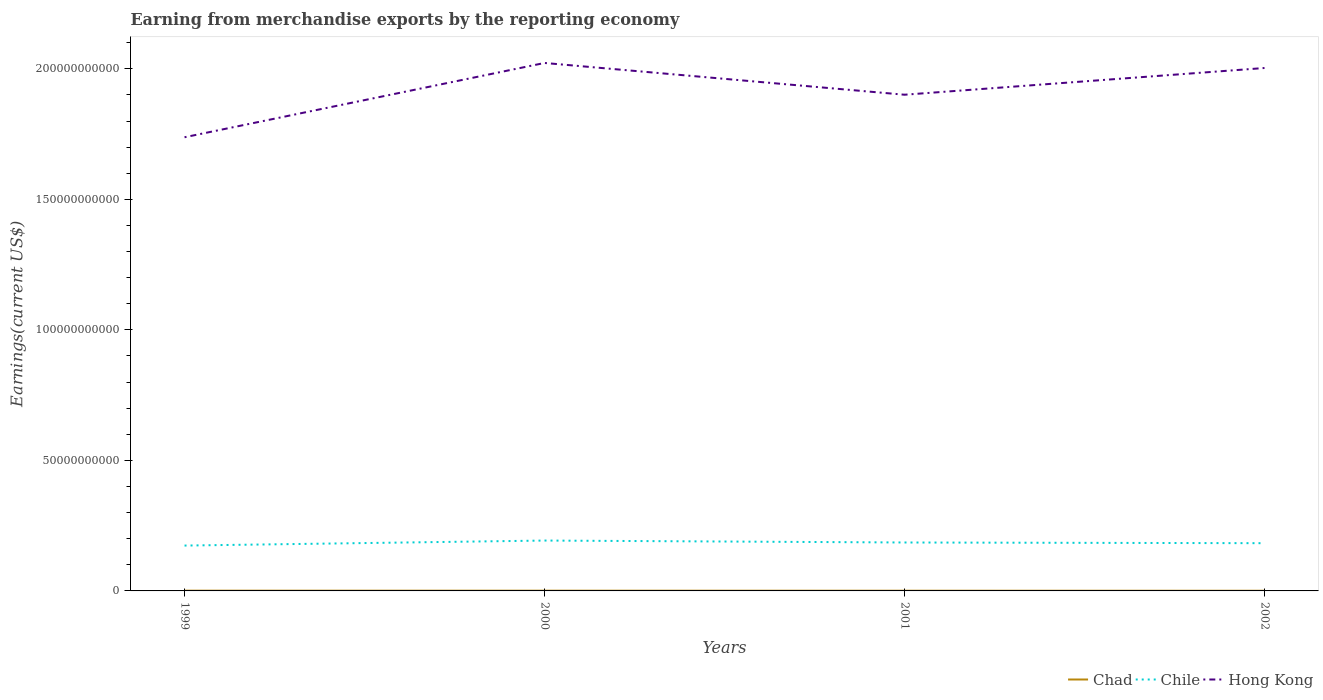Does the line corresponding to Chile intersect with the line corresponding to Chad?
Give a very brief answer. No. Is the number of lines equal to the number of legend labels?
Offer a terse response. Yes. Across all years, what is the maximum amount earned from merchandise exports in Chad?
Make the answer very short. 6.39e+07. In which year was the amount earned from merchandise exports in Chile maximum?
Your answer should be very brief. 1999. What is the total amount earned from merchandise exports in Chile in the graph?
Your answer should be very brief. -1.18e+09. What is the difference between the highest and the second highest amount earned from merchandise exports in Chile?
Ensure brevity in your answer.  1.92e+09. What is the difference between the highest and the lowest amount earned from merchandise exports in Chile?
Give a very brief answer. 2. How many lines are there?
Keep it short and to the point. 3. Are the values on the major ticks of Y-axis written in scientific E-notation?
Your answer should be very brief. No. Does the graph contain any zero values?
Your response must be concise. No. Where does the legend appear in the graph?
Offer a very short reply. Bottom right. How many legend labels are there?
Keep it short and to the point. 3. How are the legend labels stacked?
Your answer should be very brief. Horizontal. What is the title of the graph?
Offer a very short reply. Earning from merchandise exports by the reporting economy. What is the label or title of the Y-axis?
Your response must be concise. Earnings(current US$). What is the Earnings(current US$) of Chad in 1999?
Give a very brief answer. 9.81e+07. What is the Earnings(current US$) of Chile in 1999?
Ensure brevity in your answer.  1.74e+1. What is the Earnings(current US$) of Hong Kong in 1999?
Your answer should be compact. 1.74e+11. What is the Earnings(current US$) in Chad in 2000?
Ensure brevity in your answer.  8.76e+07. What is the Earnings(current US$) of Chile in 2000?
Your answer should be compact. 1.93e+1. What is the Earnings(current US$) of Hong Kong in 2000?
Make the answer very short. 2.02e+11. What is the Earnings(current US$) in Chad in 2001?
Your response must be concise. 7.66e+07. What is the Earnings(current US$) in Chile in 2001?
Offer a terse response. 1.86e+1. What is the Earnings(current US$) of Hong Kong in 2001?
Ensure brevity in your answer.  1.90e+11. What is the Earnings(current US$) in Chad in 2002?
Ensure brevity in your answer.  6.39e+07. What is the Earnings(current US$) of Chile in 2002?
Keep it short and to the point. 1.83e+1. What is the Earnings(current US$) of Hong Kong in 2002?
Keep it short and to the point. 2.00e+11. Across all years, what is the maximum Earnings(current US$) in Chad?
Keep it short and to the point. 9.81e+07. Across all years, what is the maximum Earnings(current US$) of Chile?
Give a very brief answer. 1.93e+1. Across all years, what is the maximum Earnings(current US$) in Hong Kong?
Give a very brief answer. 2.02e+11. Across all years, what is the minimum Earnings(current US$) in Chad?
Your answer should be compact. 6.39e+07. Across all years, what is the minimum Earnings(current US$) of Chile?
Your answer should be very brief. 1.74e+1. Across all years, what is the minimum Earnings(current US$) of Hong Kong?
Provide a short and direct response. 1.74e+11. What is the total Earnings(current US$) in Chad in the graph?
Keep it short and to the point. 3.26e+08. What is the total Earnings(current US$) of Chile in the graph?
Provide a succinct answer. 7.35e+1. What is the total Earnings(current US$) in Hong Kong in the graph?
Keep it short and to the point. 7.66e+11. What is the difference between the Earnings(current US$) in Chad in 1999 and that in 2000?
Provide a short and direct response. 1.05e+07. What is the difference between the Earnings(current US$) of Chile in 1999 and that in 2000?
Keep it short and to the point. -1.92e+09. What is the difference between the Earnings(current US$) of Hong Kong in 1999 and that in 2000?
Offer a very short reply. -2.85e+1. What is the difference between the Earnings(current US$) in Chad in 1999 and that in 2001?
Provide a short and direct response. 2.15e+07. What is the difference between the Earnings(current US$) in Chile in 1999 and that in 2001?
Make the answer very short. -1.18e+09. What is the difference between the Earnings(current US$) in Hong Kong in 1999 and that in 2001?
Provide a succinct answer. -1.63e+1. What is the difference between the Earnings(current US$) of Chad in 1999 and that in 2002?
Offer a very short reply. 3.42e+07. What is the difference between the Earnings(current US$) of Chile in 1999 and that in 2002?
Give a very brief answer. -9.09e+08. What is the difference between the Earnings(current US$) of Hong Kong in 1999 and that in 2002?
Your answer should be compact. -2.65e+1. What is the difference between the Earnings(current US$) of Chad in 2000 and that in 2001?
Provide a succinct answer. 1.10e+07. What is the difference between the Earnings(current US$) in Chile in 2000 and that in 2001?
Offer a very short reply. 7.41e+08. What is the difference between the Earnings(current US$) of Hong Kong in 2000 and that in 2001?
Your response must be concise. 1.22e+1. What is the difference between the Earnings(current US$) of Chad in 2000 and that in 2002?
Offer a terse response. 2.37e+07. What is the difference between the Earnings(current US$) in Chile in 2000 and that in 2002?
Your answer should be compact. 1.01e+09. What is the difference between the Earnings(current US$) of Hong Kong in 2000 and that in 2002?
Your answer should be compact. 1.93e+09. What is the difference between the Earnings(current US$) of Chad in 2001 and that in 2002?
Your response must be concise. 1.27e+07. What is the difference between the Earnings(current US$) of Chile in 2001 and that in 2002?
Ensure brevity in your answer.  2.69e+08. What is the difference between the Earnings(current US$) in Hong Kong in 2001 and that in 2002?
Give a very brief answer. -1.02e+1. What is the difference between the Earnings(current US$) in Chad in 1999 and the Earnings(current US$) in Chile in 2000?
Provide a short and direct response. -1.92e+1. What is the difference between the Earnings(current US$) in Chad in 1999 and the Earnings(current US$) in Hong Kong in 2000?
Ensure brevity in your answer.  -2.02e+11. What is the difference between the Earnings(current US$) in Chile in 1999 and the Earnings(current US$) in Hong Kong in 2000?
Provide a succinct answer. -1.85e+11. What is the difference between the Earnings(current US$) of Chad in 1999 and the Earnings(current US$) of Chile in 2001?
Your answer should be compact. -1.85e+1. What is the difference between the Earnings(current US$) of Chad in 1999 and the Earnings(current US$) of Hong Kong in 2001?
Give a very brief answer. -1.90e+11. What is the difference between the Earnings(current US$) in Chile in 1999 and the Earnings(current US$) in Hong Kong in 2001?
Offer a very short reply. -1.73e+11. What is the difference between the Earnings(current US$) in Chad in 1999 and the Earnings(current US$) in Chile in 2002?
Provide a succinct answer. -1.82e+1. What is the difference between the Earnings(current US$) of Chad in 1999 and the Earnings(current US$) of Hong Kong in 2002?
Your answer should be very brief. -2.00e+11. What is the difference between the Earnings(current US$) of Chile in 1999 and the Earnings(current US$) of Hong Kong in 2002?
Provide a short and direct response. -1.83e+11. What is the difference between the Earnings(current US$) of Chad in 2000 and the Earnings(current US$) of Chile in 2001?
Your response must be concise. -1.85e+1. What is the difference between the Earnings(current US$) in Chad in 2000 and the Earnings(current US$) in Hong Kong in 2001?
Ensure brevity in your answer.  -1.90e+11. What is the difference between the Earnings(current US$) of Chile in 2000 and the Earnings(current US$) of Hong Kong in 2001?
Keep it short and to the point. -1.71e+11. What is the difference between the Earnings(current US$) of Chad in 2000 and the Earnings(current US$) of Chile in 2002?
Your response must be concise. -1.82e+1. What is the difference between the Earnings(current US$) in Chad in 2000 and the Earnings(current US$) in Hong Kong in 2002?
Your answer should be compact. -2.00e+11. What is the difference between the Earnings(current US$) in Chile in 2000 and the Earnings(current US$) in Hong Kong in 2002?
Keep it short and to the point. -1.81e+11. What is the difference between the Earnings(current US$) of Chad in 2001 and the Earnings(current US$) of Chile in 2002?
Offer a very short reply. -1.82e+1. What is the difference between the Earnings(current US$) of Chad in 2001 and the Earnings(current US$) of Hong Kong in 2002?
Provide a short and direct response. -2.00e+11. What is the difference between the Earnings(current US$) in Chile in 2001 and the Earnings(current US$) in Hong Kong in 2002?
Provide a short and direct response. -1.82e+11. What is the average Earnings(current US$) in Chad per year?
Keep it short and to the point. 8.15e+07. What is the average Earnings(current US$) in Chile per year?
Keep it short and to the point. 1.84e+1. What is the average Earnings(current US$) of Hong Kong per year?
Your response must be concise. 1.92e+11. In the year 1999, what is the difference between the Earnings(current US$) of Chad and Earnings(current US$) of Chile?
Offer a very short reply. -1.73e+1. In the year 1999, what is the difference between the Earnings(current US$) in Chad and Earnings(current US$) in Hong Kong?
Offer a very short reply. -1.74e+11. In the year 1999, what is the difference between the Earnings(current US$) of Chile and Earnings(current US$) of Hong Kong?
Provide a short and direct response. -1.56e+11. In the year 2000, what is the difference between the Earnings(current US$) in Chad and Earnings(current US$) in Chile?
Make the answer very short. -1.92e+1. In the year 2000, what is the difference between the Earnings(current US$) of Chad and Earnings(current US$) of Hong Kong?
Offer a very short reply. -2.02e+11. In the year 2000, what is the difference between the Earnings(current US$) of Chile and Earnings(current US$) of Hong Kong?
Provide a succinct answer. -1.83e+11. In the year 2001, what is the difference between the Earnings(current US$) of Chad and Earnings(current US$) of Chile?
Make the answer very short. -1.85e+1. In the year 2001, what is the difference between the Earnings(current US$) of Chad and Earnings(current US$) of Hong Kong?
Your response must be concise. -1.90e+11. In the year 2001, what is the difference between the Earnings(current US$) in Chile and Earnings(current US$) in Hong Kong?
Give a very brief answer. -1.72e+11. In the year 2002, what is the difference between the Earnings(current US$) in Chad and Earnings(current US$) in Chile?
Provide a succinct answer. -1.82e+1. In the year 2002, what is the difference between the Earnings(current US$) in Chad and Earnings(current US$) in Hong Kong?
Your answer should be very brief. -2.00e+11. In the year 2002, what is the difference between the Earnings(current US$) of Chile and Earnings(current US$) of Hong Kong?
Your answer should be compact. -1.82e+11. What is the ratio of the Earnings(current US$) of Chad in 1999 to that in 2000?
Your answer should be very brief. 1.12. What is the ratio of the Earnings(current US$) of Chile in 1999 to that in 2000?
Offer a terse response. 0.9. What is the ratio of the Earnings(current US$) in Hong Kong in 1999 to that in 2000?
Offer a very short reply. 0.86. What is the ratio of the Earnings(current US$) of Chad in 1999 to that in 2001?
Provide a succinct answer. 1.28. What is the ratio of the Earnings(current US$) in Chile in 1999 to that in 2001?
Your response must be concise. 0.94. What is the ratio of the Earnings(current US$) of Hong Kong in 1999 to that in 2001?
Provide a succinct answer. 0.91. What is the ratio of the Earnings(current US$) in Chad in 1999 to that in 2002?
Offer a very short reply. 1.54. What is the ratio of the Earnings(current US$) of Chile in 1999 to that in 2002?
Make the answer very short. 0.95. What is the ratio of the Earnings(current US$) of Hong Kong in 1999 to that in 2002?
Provide a short and direct response. 0.87. What is the ratio of the Earnings(current US$) of Chad in 2000 to that in 2001?
Offer a very short reply. 1.14. What is the ratio of the Earnings(current US$) in Chile in 2000 to that in 2001?
Your answer should be compact. 1.04. What is the ratio of the Earnings(current US$) of Hong Kong in 2000 to that in 2001?
Keep it short and to the point. 1.06. What is the ratio of the Earnings(current US$) in Chad in 2000 to that in 2002?
Provide a succinct answer. 1.37. What is the ratio of the Earnings(current US$) in Chile in 2000 to that in 2002?
Provide a short and direct response. 1.06. What is the ratio of the Earnings(current US$) in Hong Kong in 2000 to that in 2002?
Provide a succinct answer. 1.01. What is the ratio of the Earnings(current US$) in Chad in 2001 to that in 2002?
Ensure brevity in your answer.  1.2. What is the ratio of the Earnings(current US$) of Chile in 2001 to that in 2002?
Your answer should be very brief. 1.01. What is the ratio of the Earnings(current US$) of Hong Kong in 2001 to that in 2002?
Offer a terse response. 0.95. What is the difference between the highest and the second highest Earnings(current US$) of Chad?
Offer a terse response. 1.05e+07. What is the difference between the highest and the second highest Earnings(current US$) in Chile?
Your response must be concise. 7.41e+08. What is the difference between the highest and the second highest Earnings(current US$) in Hong Kong?
Keep it short and to the point. 1.93e+09. What is the difference between the highest and the lowest Earnings(current US$) of Chad?
Your answer should be compact. 3.42e+07. What is the difference between the highest and the lowest Earnings(current US$) of Chile?
Give a very brief answer. 1.92e+09. What is the difference between the highest and the lowest Earnings(current US$) in Hong Kong?
Provide a succinct answer. 2.85e+1. 